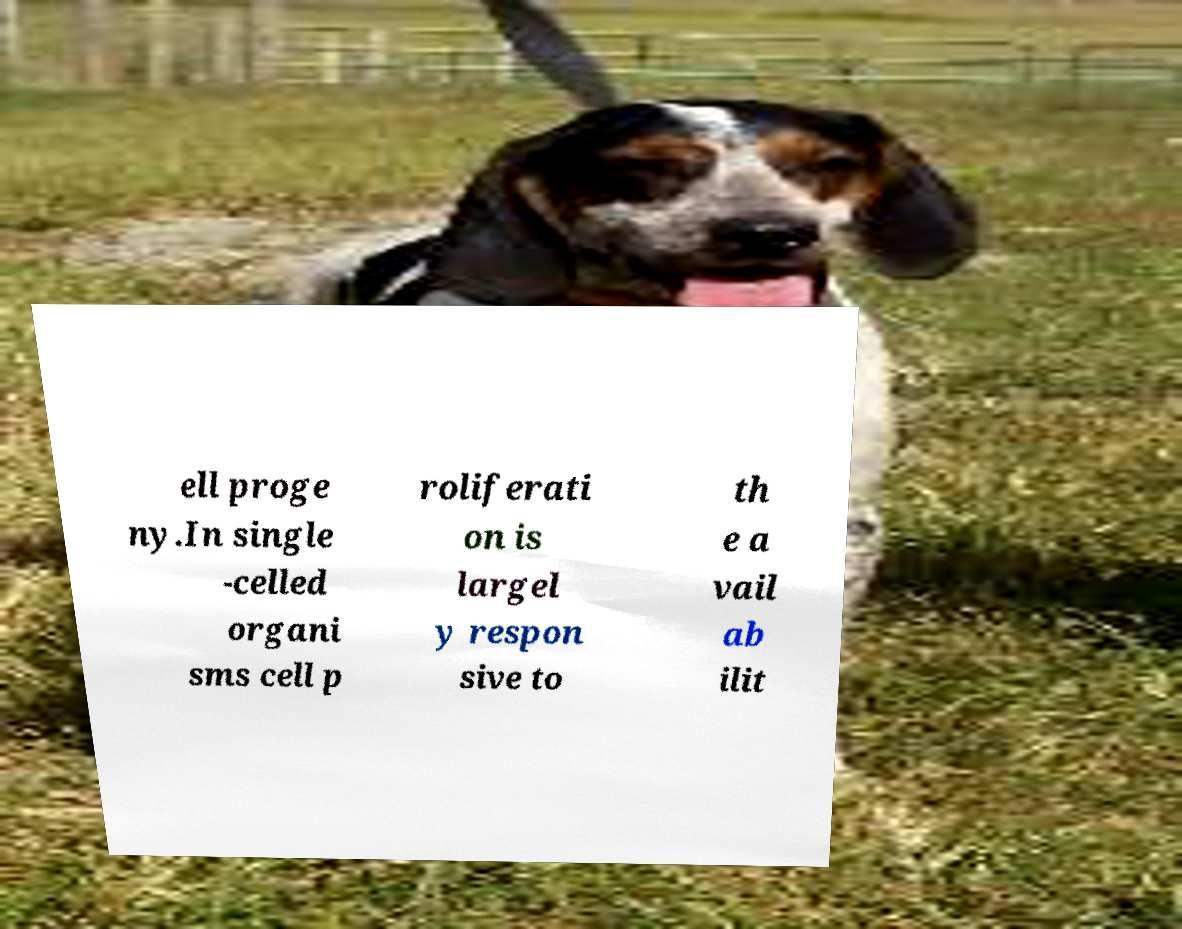Please read and relay the text visible in this image. What does it say? ell proge ny.In single -celled organi sms cell p roliferati on is largel y respon sive to th e a vail ab ilit 